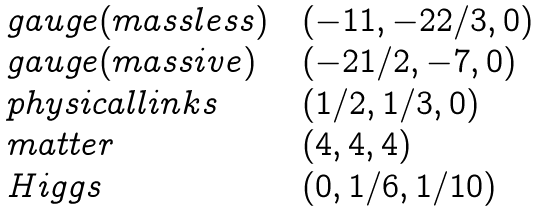<formula> <loc_0><loc_0><loc_500><loc_500>\begin{array} { l c l } g a u g e ( m a s s l e s s ) & & ( - 1 1 , - 2 2 / 3 , 0 ) \\ g a u g e ( m a s s i v e ) & & ( - 2 1 / 2 , - 7 , 0 ) \\ p h y s i c a l l i n k s & & ( 1 / 2 , 1 / 3 , 0 ) \\ m a t t e r & & ( 4 , 4 , 4 ) \\ H i g g s & & ( 0 , 1 / 6 , 1 / 1 0 ) \end{array}</formula> 